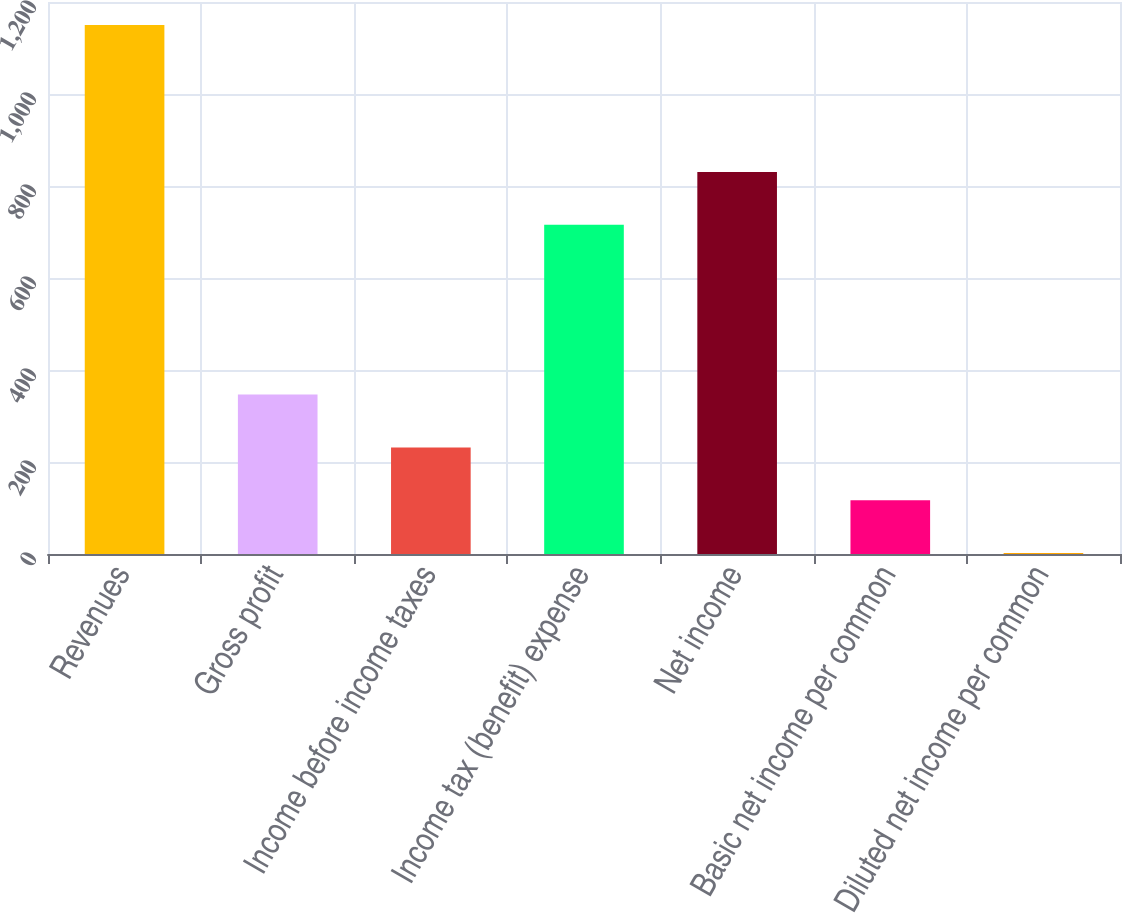Convert chart to OTSL. <chart><loc_0><loc_0><loc_500><loc_500><bar_chart><fcel>Revenues<fcel>Gross profit<fcel>Income before income taxes<fcel>Income tax (benefit) expense<fcel>Net income<fcel>Basic net income per common<fcel>Diluted net income per common<nl><fcel>1150<fcel>346.56<fcel>231.78<fcel>715.6<fcel>830.38<fcel>117<fcel>2.22<nl></chart> 